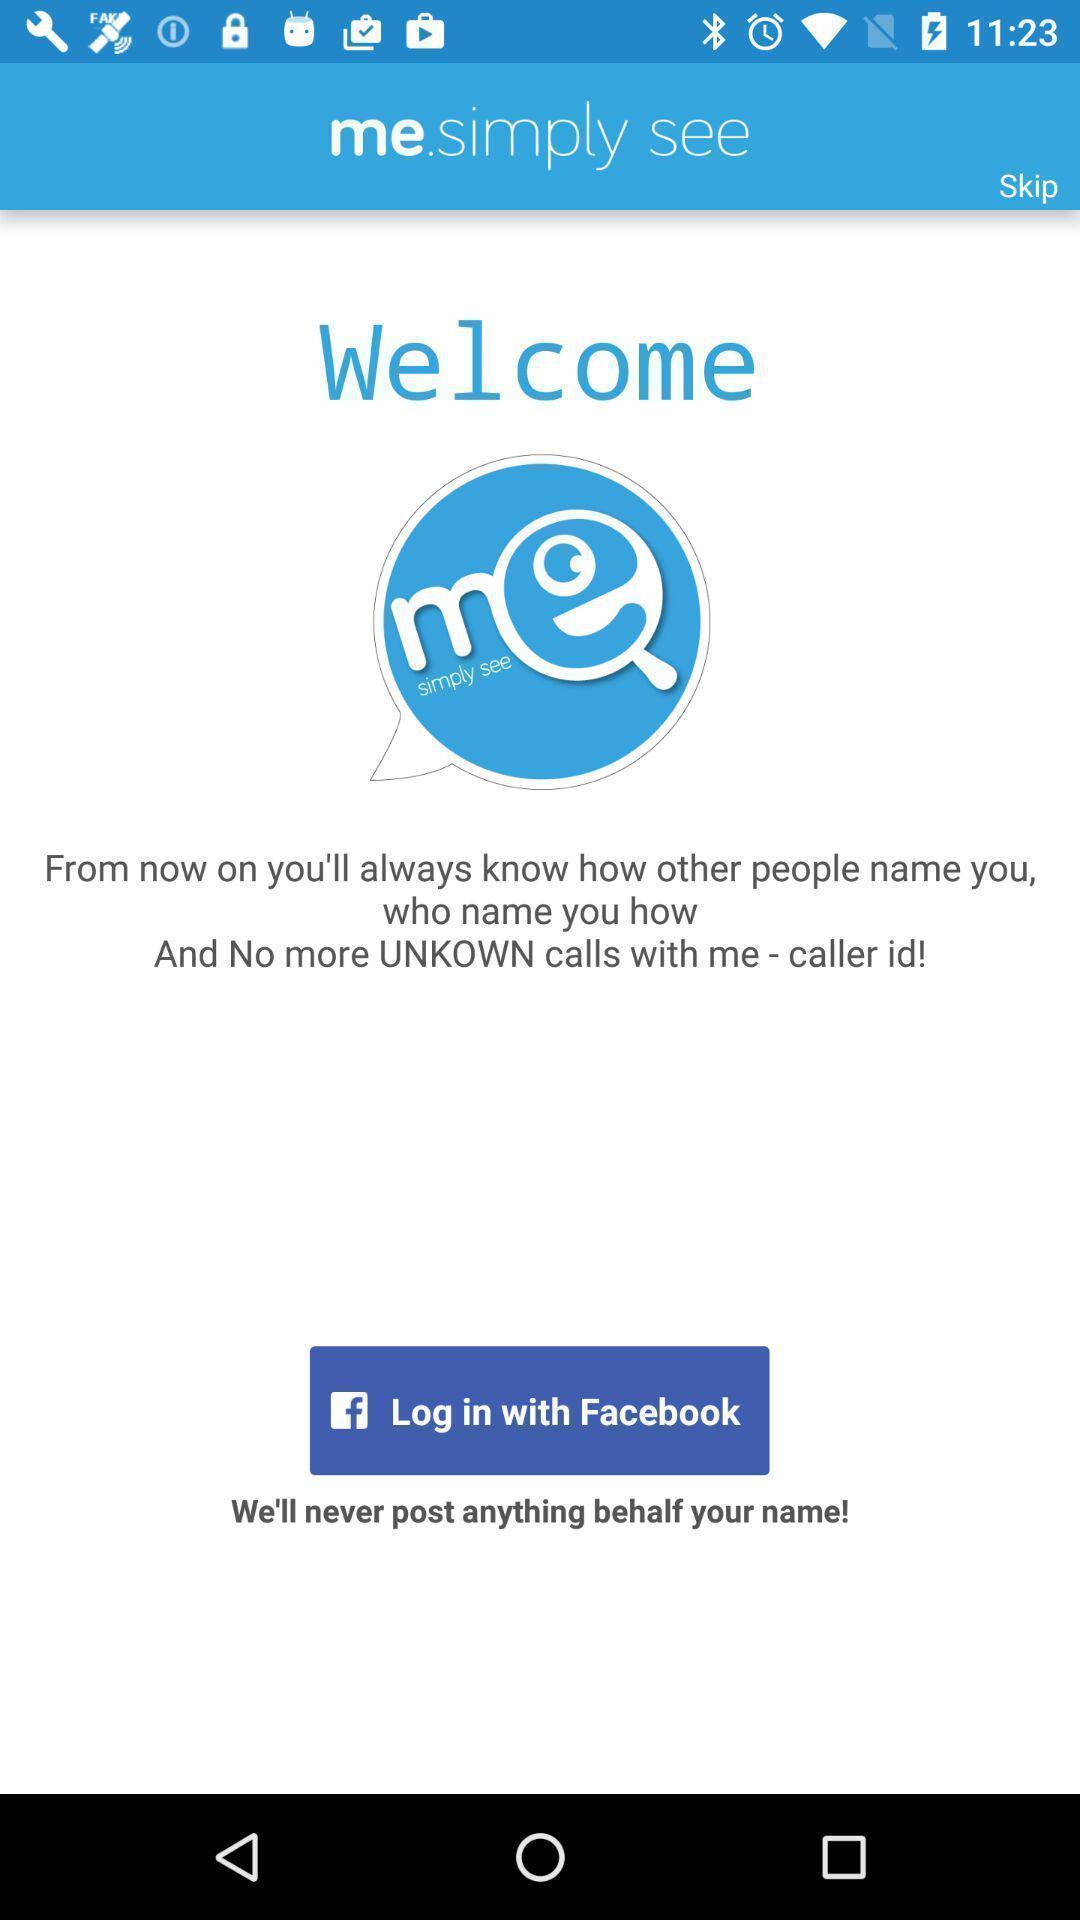Summarize the information in this screenshot. Welcome page of social app. 